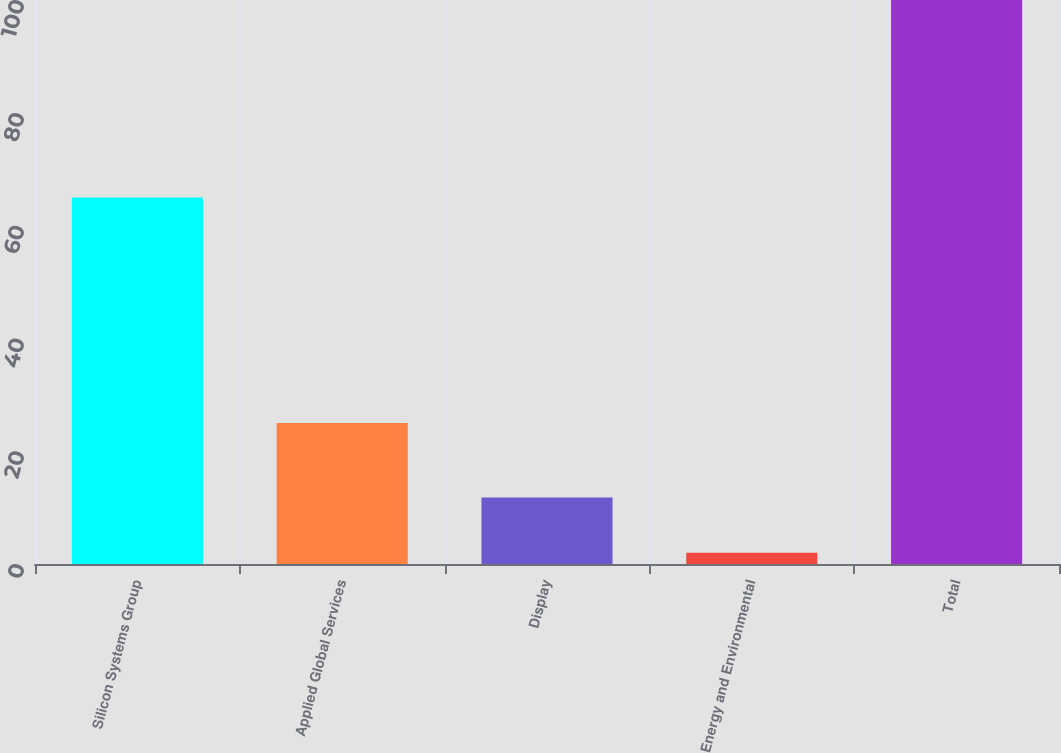<chart> <loc_0><loc_0><loc_500><loc_500><bar_chart><fcel>Silicon Systems Group<fcel>Applied Global Services<fcel>Display<fcel>Energy and Environmental<fcel>Total<nl><fcel>65<fcel>25<fcel>11.8<fcel>2<fcel>100<nl></chart> 